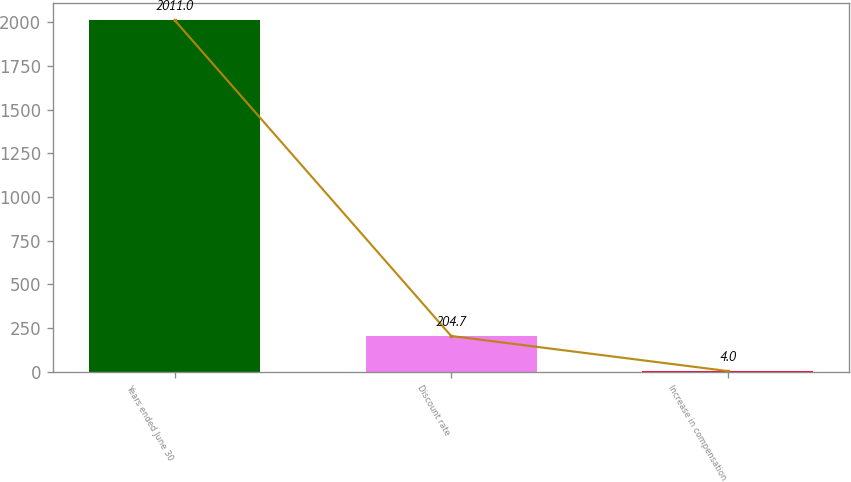<chart> <loc_0><loc_0><loc_500><loc_500><bar_chart><fcel>Years ended June 30<fcel>Discount rate<fcel>Increase in compensation<nl><fcel>2011<fcel>204.7<fcel>4<nl></chart> 